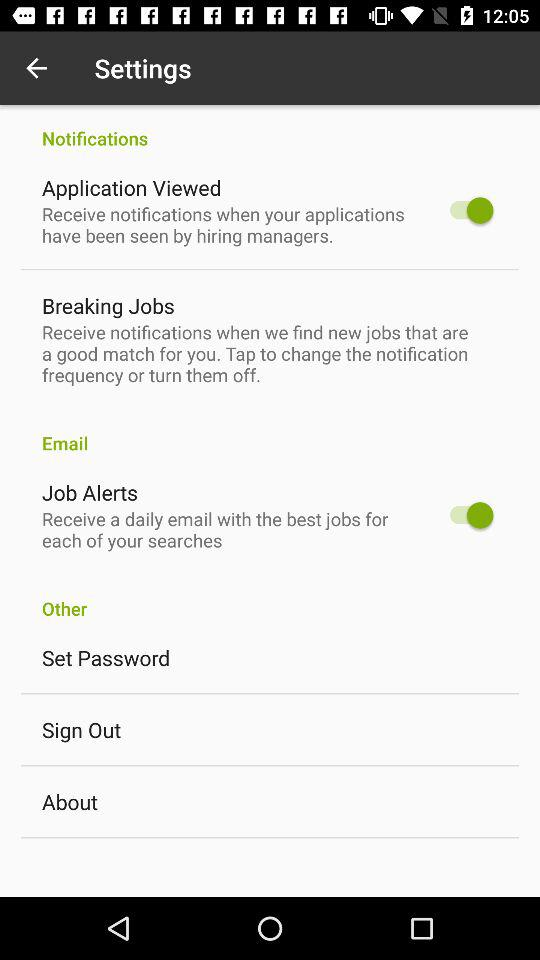What is the status of the "Job Alerts"? The status is "on". 